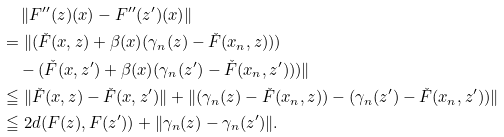Convert formula to latex. <formula><loc_0><loc_0><loc_500><loc_500>& \quad \, \| F ^ { \prime \prime } ( z ) ( x ) - F ^ { \prime \prime } ( z ^ { \prime } ) ( x ) \| \\ & = \| ( \check { F } ( x , z ) + \beta ( x ) ( \gamma _ { n } ( z ) - \check { F } ( x _ { n } , z ) ) ) \\ & \quad - ( \check { F } ( x , z ^ { \prime } ) + \beta ( x ) ( \gamma _ { n } ( z ^ { \prime } ) - \check { F } ( x _ { n } , z ^ { \prime } ) ) ) \| \\ & \leqq \| \check { F } ( x , z ) - \check { F } ( x , z ^ { \prime } ) \| + \| ( \gamma _ { n } ( z ) - \check { F } ( x _ { n } , z ) ) - ( \gamma _ { n } ( z ^ { \prime } ) - \check { F } ( x _ { n } , z ^ { \prime } ) ) \| \\ & \leqq 2 d ( F ( z ) , F ( z ^ { \prime } ) ) + \| \gamma _ { n } ( z ) - \gamma _ { n } ( z ^ { \prime } ) \| .</formula> 